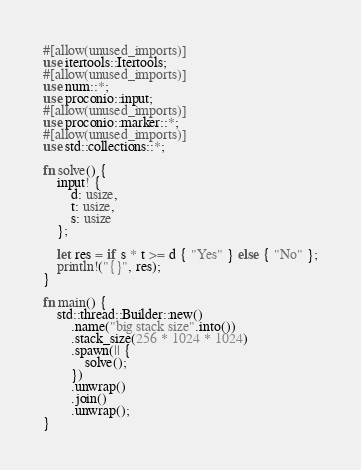<code> <loc_0><loc_0><loc_500><loc_500><_Rust_>#[allow(unused_imports)]
use itertools::Itertools;
#[allow(unused_imports)]
use num::*;
use proconio::input;
#[allow(unused_imports)]
use proconio::marker::*;
#[allow(unused_imports)]
use std::collections::*;

fn solve() {
    input! {
        d: usize,
        t: usize,
        s: usize
    };

    let res = if s * t >= d { "Yes" } else { "No" };
    println!("{}", res);
}

fn main() {
    std::thread::Builder::new()
        .name("big stack size".into())
        .stack_size(256 * 1024 * 1024)
        .spawn(|| {
            solve();
        })
        .unwrap()
        .join()
        .unwrap();
}
</code> 